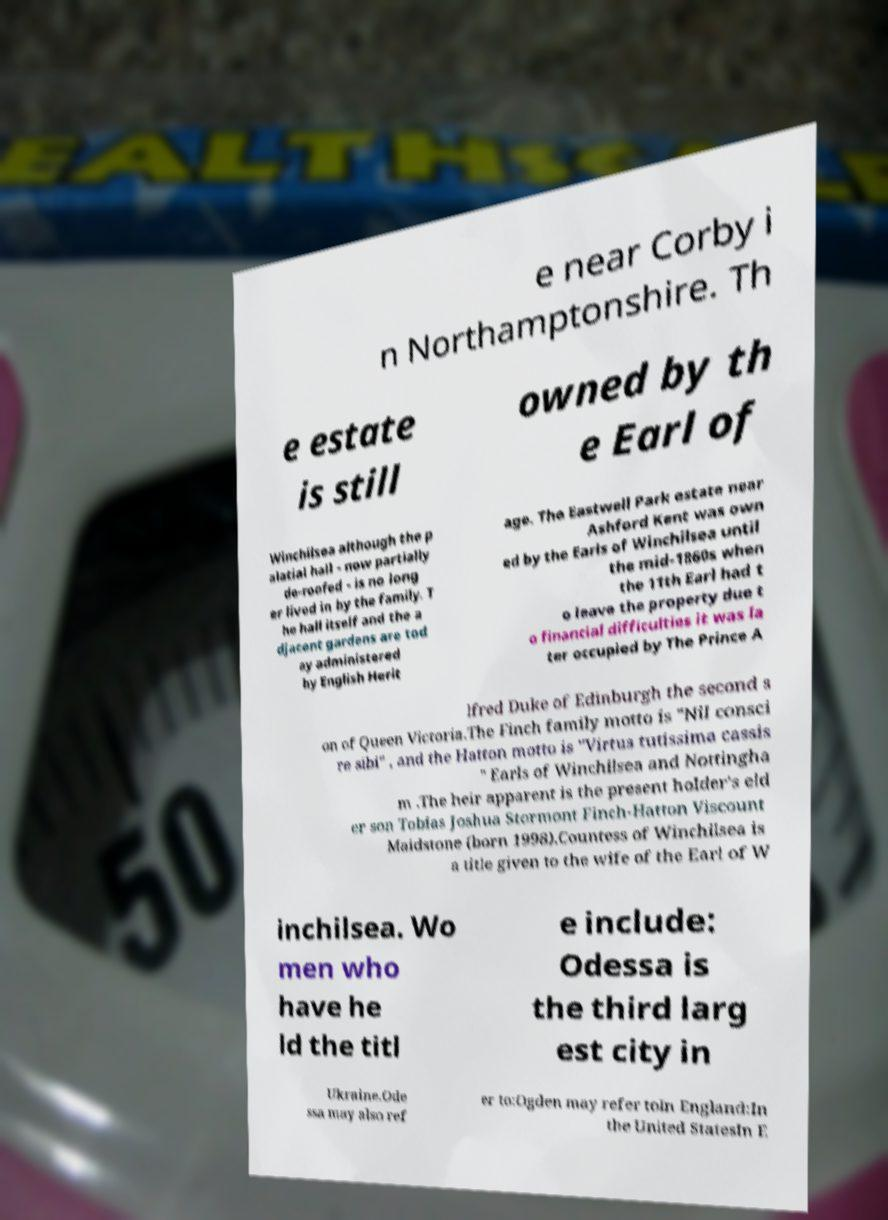Please read and relay the text visible in this image. What does it say? e near Corby i n Northamptonshire. Th e estate is still owned by th e Earl of Winchilsea although the p alatial hall - now partially de-roofed - is no long er lived in by the family. T he hall itself and the a djacent gardens are tod ay administered by English Herit age. The Eastwell Park estate near Ashford Kent was own ed by the Earls of Winchilsea until the mid-1860s when the 11th Earl had t o leave the property due t o financial difficulties it was la ter occupied by The Prince A lfred Duke of Edinburgh the second s on of Queen Victoria.The Finch family motto is "Nil consci re sibi" , and the Hatton motto is "Virtus tutissima cassis " Earls of Winchilsea and Nottingha m .The heir apparent is the present holder's eld er son Tobias Joshua Stormont Finch-Hatton Viscount Maidstone (born 1998).Countess of Winchilsea is a title given to the wife of the Earl of W inchilsea. Wo men who have he ld the titl e include: Odessa is the third larg est city in Ukraine.Ode ssa may also ref er to:Ogden may refer toIn England:In the United StatesIn E 